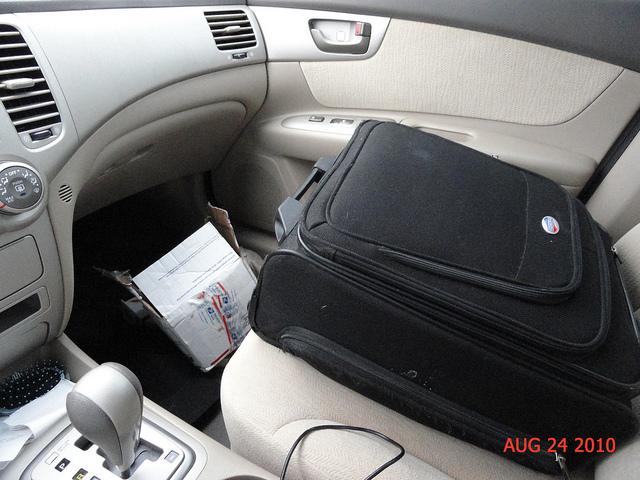Is the door locked?
Quick response, please. No. Are those leather seats?
Give a very brief answer. No. When was this picture taken?
Give a very brief answer. August 24, 2010. 